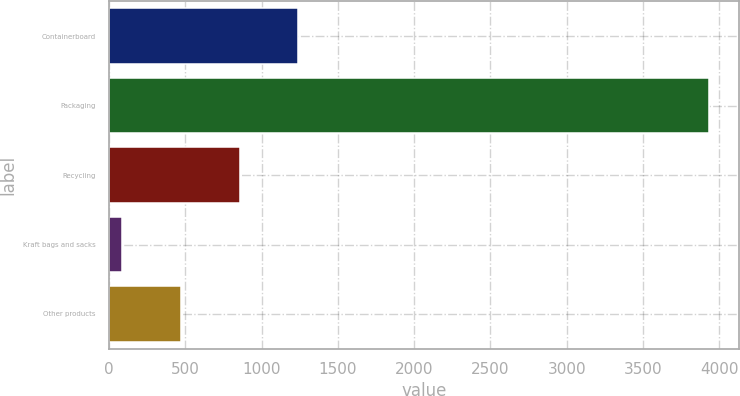Convert chart to OTSL. <chart><loc_0><loc_0><loc_500><loc_500><bar_chart><fcel>Containerboard<fcel>Packaging<fcel>Recycling<fcel>Kraft bags and sacks<fcel>Other products<nl><fcel>1240.9<fcel>3931<fcel>856.6<fcel>88<fcel>472.3<nl></chart> 